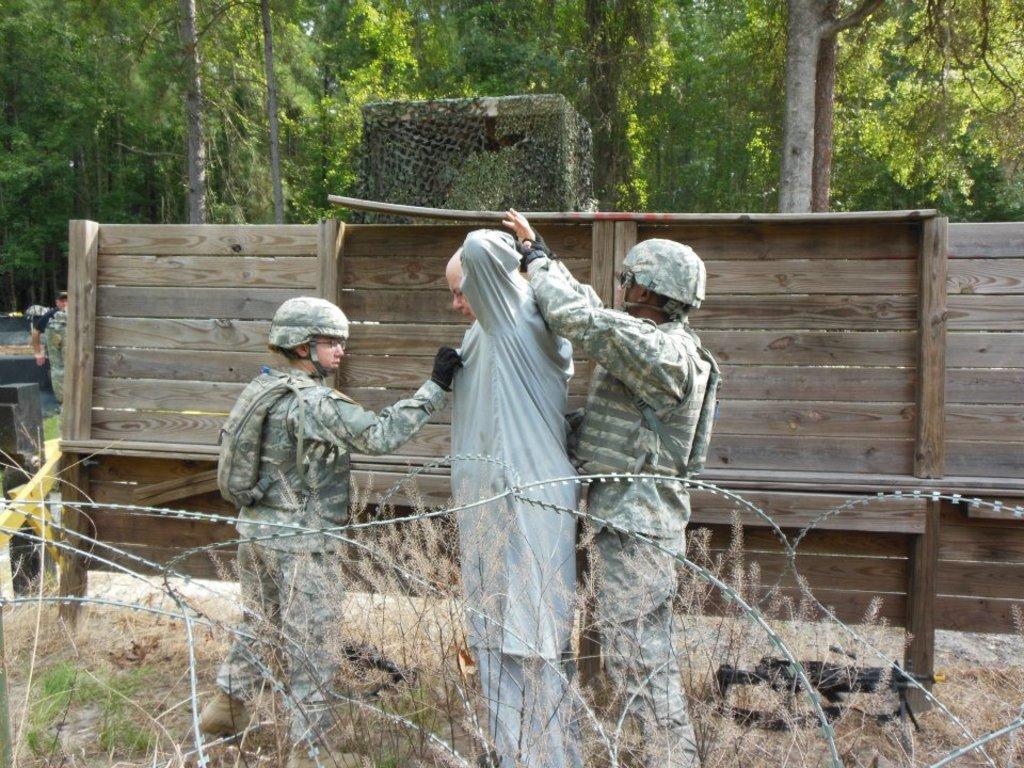Can you describe this image briefly? In this picture I can observe three members in the middle of the picture. In the bottom of the picture I can observe fence. Behind the people I can observe wooden wall. In the background there are trees. 